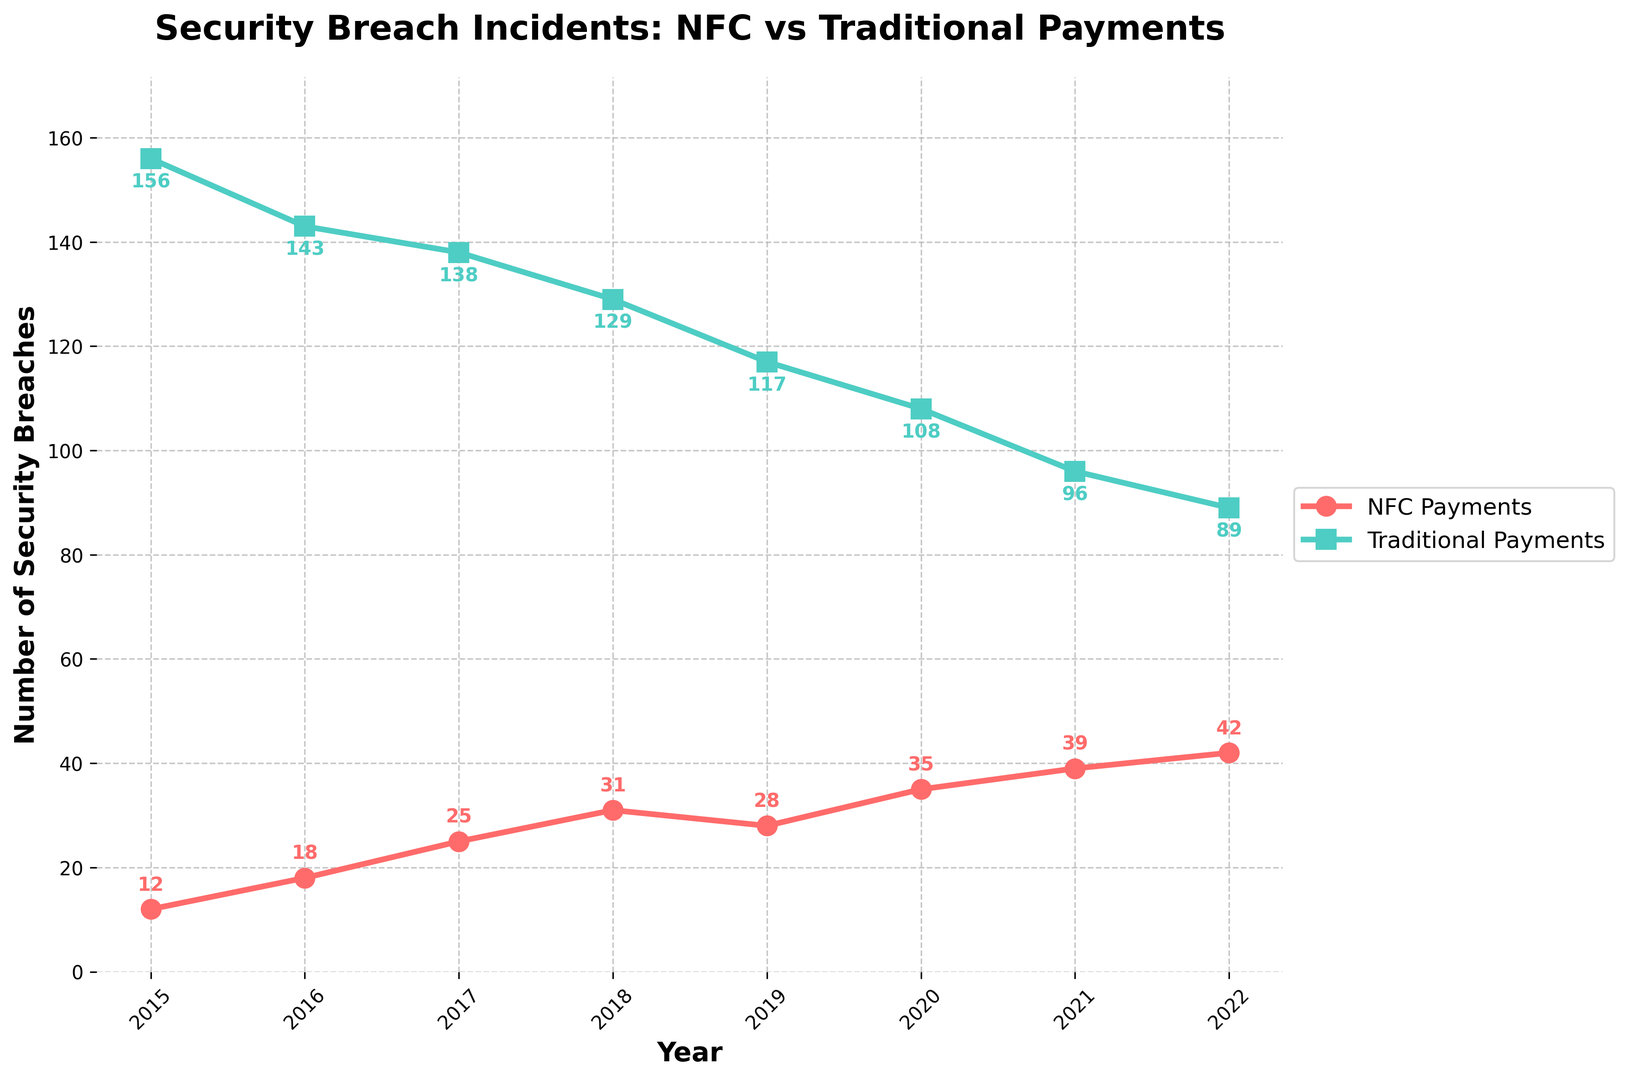What are the total number of security breaches in NFC and traditional payments in 2022 combined? To find the total, add the number of breaches for NFC payments and traditional payments in 2022. For NFC: 42, Traditional: 89. The total is 42 + 89 = 131.
Answer: 131 How many more security breaches occurred in traditional payment systems compared to NFC payments in 2015? To find the difference, subtract the number of NFC payment breaches from the number of traditional payment breaches in 2015. Traditional: 156, NFC: 12. The difference is 156 - 12 = 144.
Answer: 144 Which payment method had a higher number of security breaches in 2020, and by how much? Compare the number of breaches in 2020 for both methods. NFC: 35, Traditional: 108. Traditional had higher breaches. The difference is 108 - 35 = 73.
Answer: Traditional, by 73 Between which consecutive years did NFC payments see the largest increase in security breaches? Calculate the annual increase for NFC breaches:  
2015-2016 (18 - 12 = 6),  
2016-2017 (25 - 18 = 7),  
2017-2018 (31 - 25 = 6),  
2018-2019 (28 - 31 = -3),  
2019-2020 (35 - 28 = 7),  
2020-2021 (39 - 35 = 4),  
2021-2022 (42 - 39 = 3).  
The largest increase is 7 between 2016-2017 and 2019-2020.
Answer: 2016-2017 and 2019-2020 What is the average number of security breaches for NFC payments over the 8 years? To find the average: sum the NFC breaches over 8 years and divide by 8.  
(12+18+25+31+28+35+39+42) = 230, Average = 230 / 8 = 28.75.
Answer: 28.75 In which year did traditional payment systems see the lowest number of security breaches? Review the traditional breaches data for each year:  
2015: 156, 2016: 143, 2017: 138, 2018: 129, 2019: 117, 2020: 108, 2021: 96, 2022: 89. The lowest is in 2022.
Answer: 2022 What is the trend in the number of NFC payment breaches from 2015 to 2022? Observe the increase in values each year:  
2015: 12,
2016: 18,
2017: 25,
2018: 31,
2019: 28,
2020: 35,
2021: 39,
2022: 42.  
The trend shows an overall increase over the years, despite a slight drop in 2019.
Answer: Increasing trend By what percentage did traditional payment breaches decrease from 2018 to 2022? First, calculate the decrease: 129 - 89 = 40. Then divide by the original number (2018 value), and multiply by 100 to get the percentage: (40/129) * 100 ≈ 31.01%.
Answer: 31% Which payment method consistently had fewer breaches from 2015 to 2022? Compare the yearly breaches for both methods. In all years, the number of breaches in NFC payments is lower than those in traditional payments.
Answer: NFC Payments 